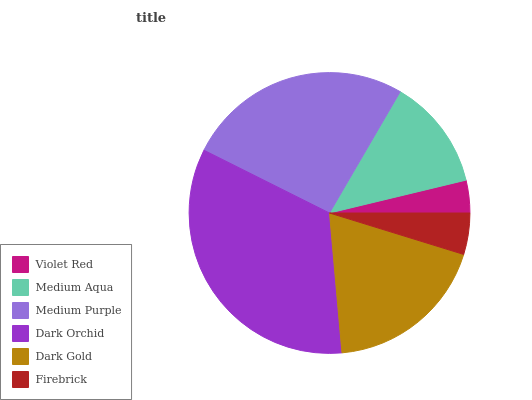Is Violet Red the minimum?
Answer yes or no. Yes. Is Dark Orchid the maximum?
Answer yes or no. Yes. Is Medium Aqua the minimum?
Answer yes or no. No. Is Medium Aqua the maximum?
Answer yes or no. No. Is Medium Aqua greater than Violet Red?
Answer yes or no. Yes. Is Violet Red less than Medium Aqua?
Answer yes or no. Yes. Is Violet Red greater than Medium Aqua?
Answer yes or no. No. Is Medium Aqua less than Violet Red?
Answer yes or no. No. Is Dark Gold the high median?
Answer yes or no. Yes. Is Medium Aqua the low median?
Answer yes or no. Yes. Is Dark Orchid the high median?
Answer yes or no. No. Is Firebrick the low median?
Answer yes or no. No. 